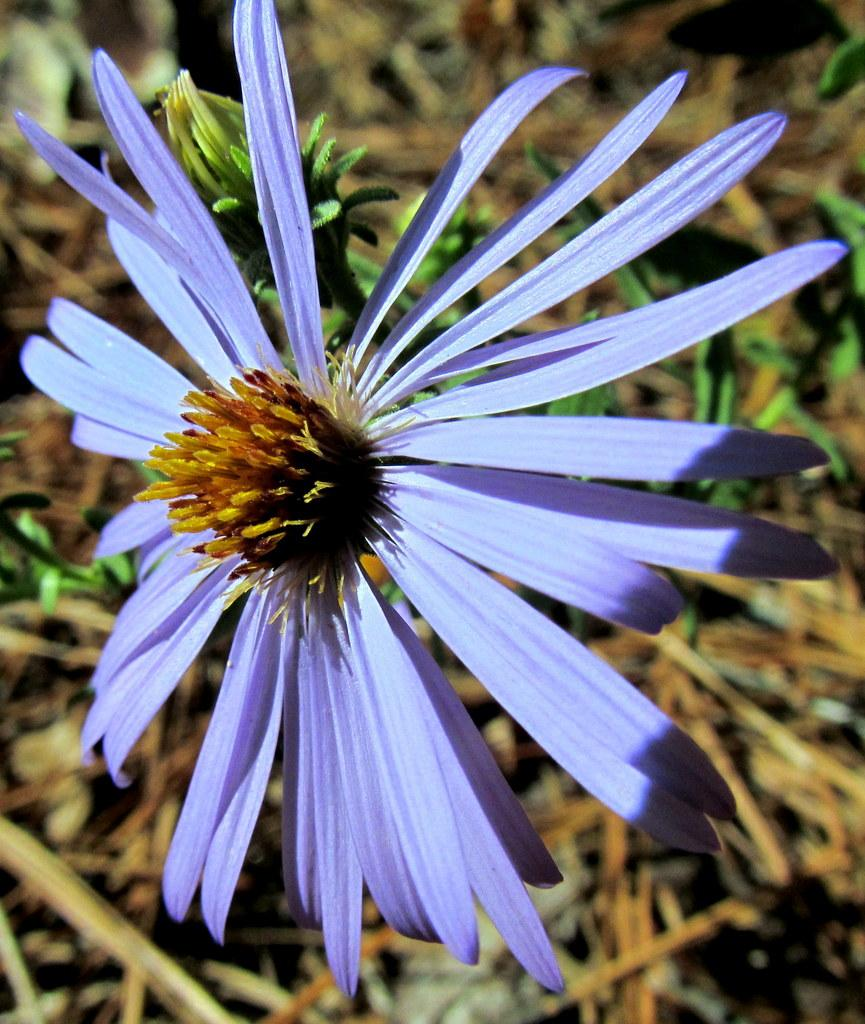What is the main subject of the picture? The main subject of the picture is a flower. Can you describe the background of the picture? The background of the picture is blurred. What type of yoke is attached to the scarecrow in the image? There is no yoke or scarecrow present in the image; it features a flower with a blurred background. What is the price of the flower in the image? The image does not provide information about the price of the flower. 